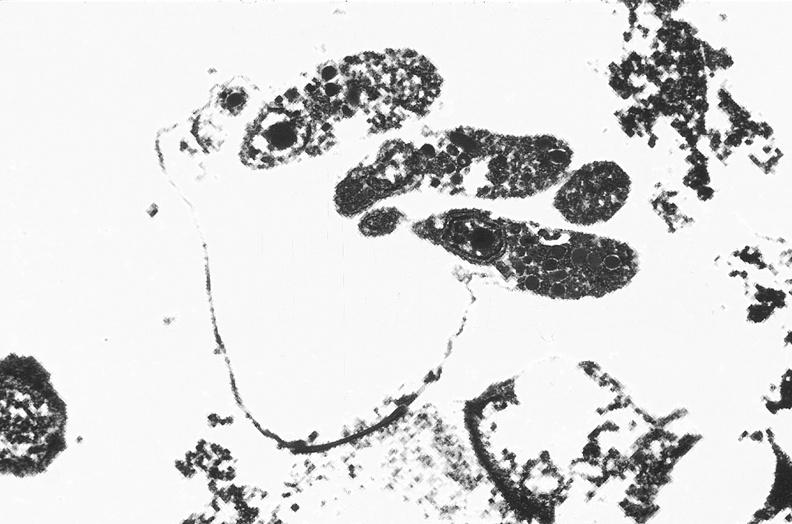what does this image show?
Answer the question using a single word or phrase. Colon 